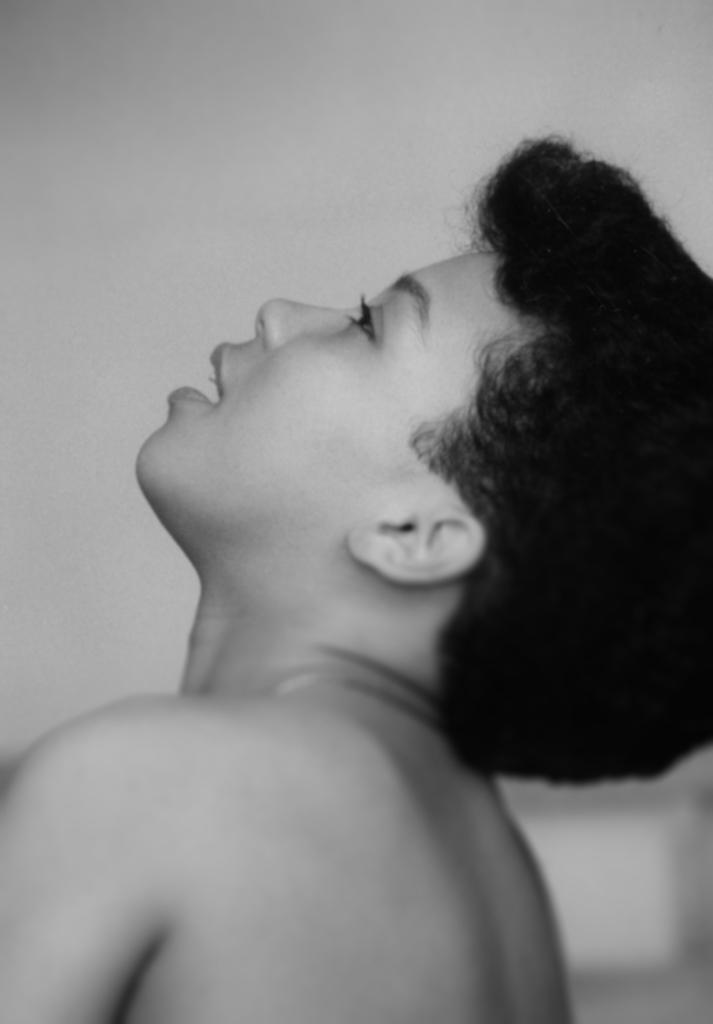Who is present in the image? There is a woman in the image. What can be seen in the background of the image? There is a wall in the background of the image. What type of hammer is the woman using to join the wind in the image? There is no hammer, joining, or wind present in the image. 